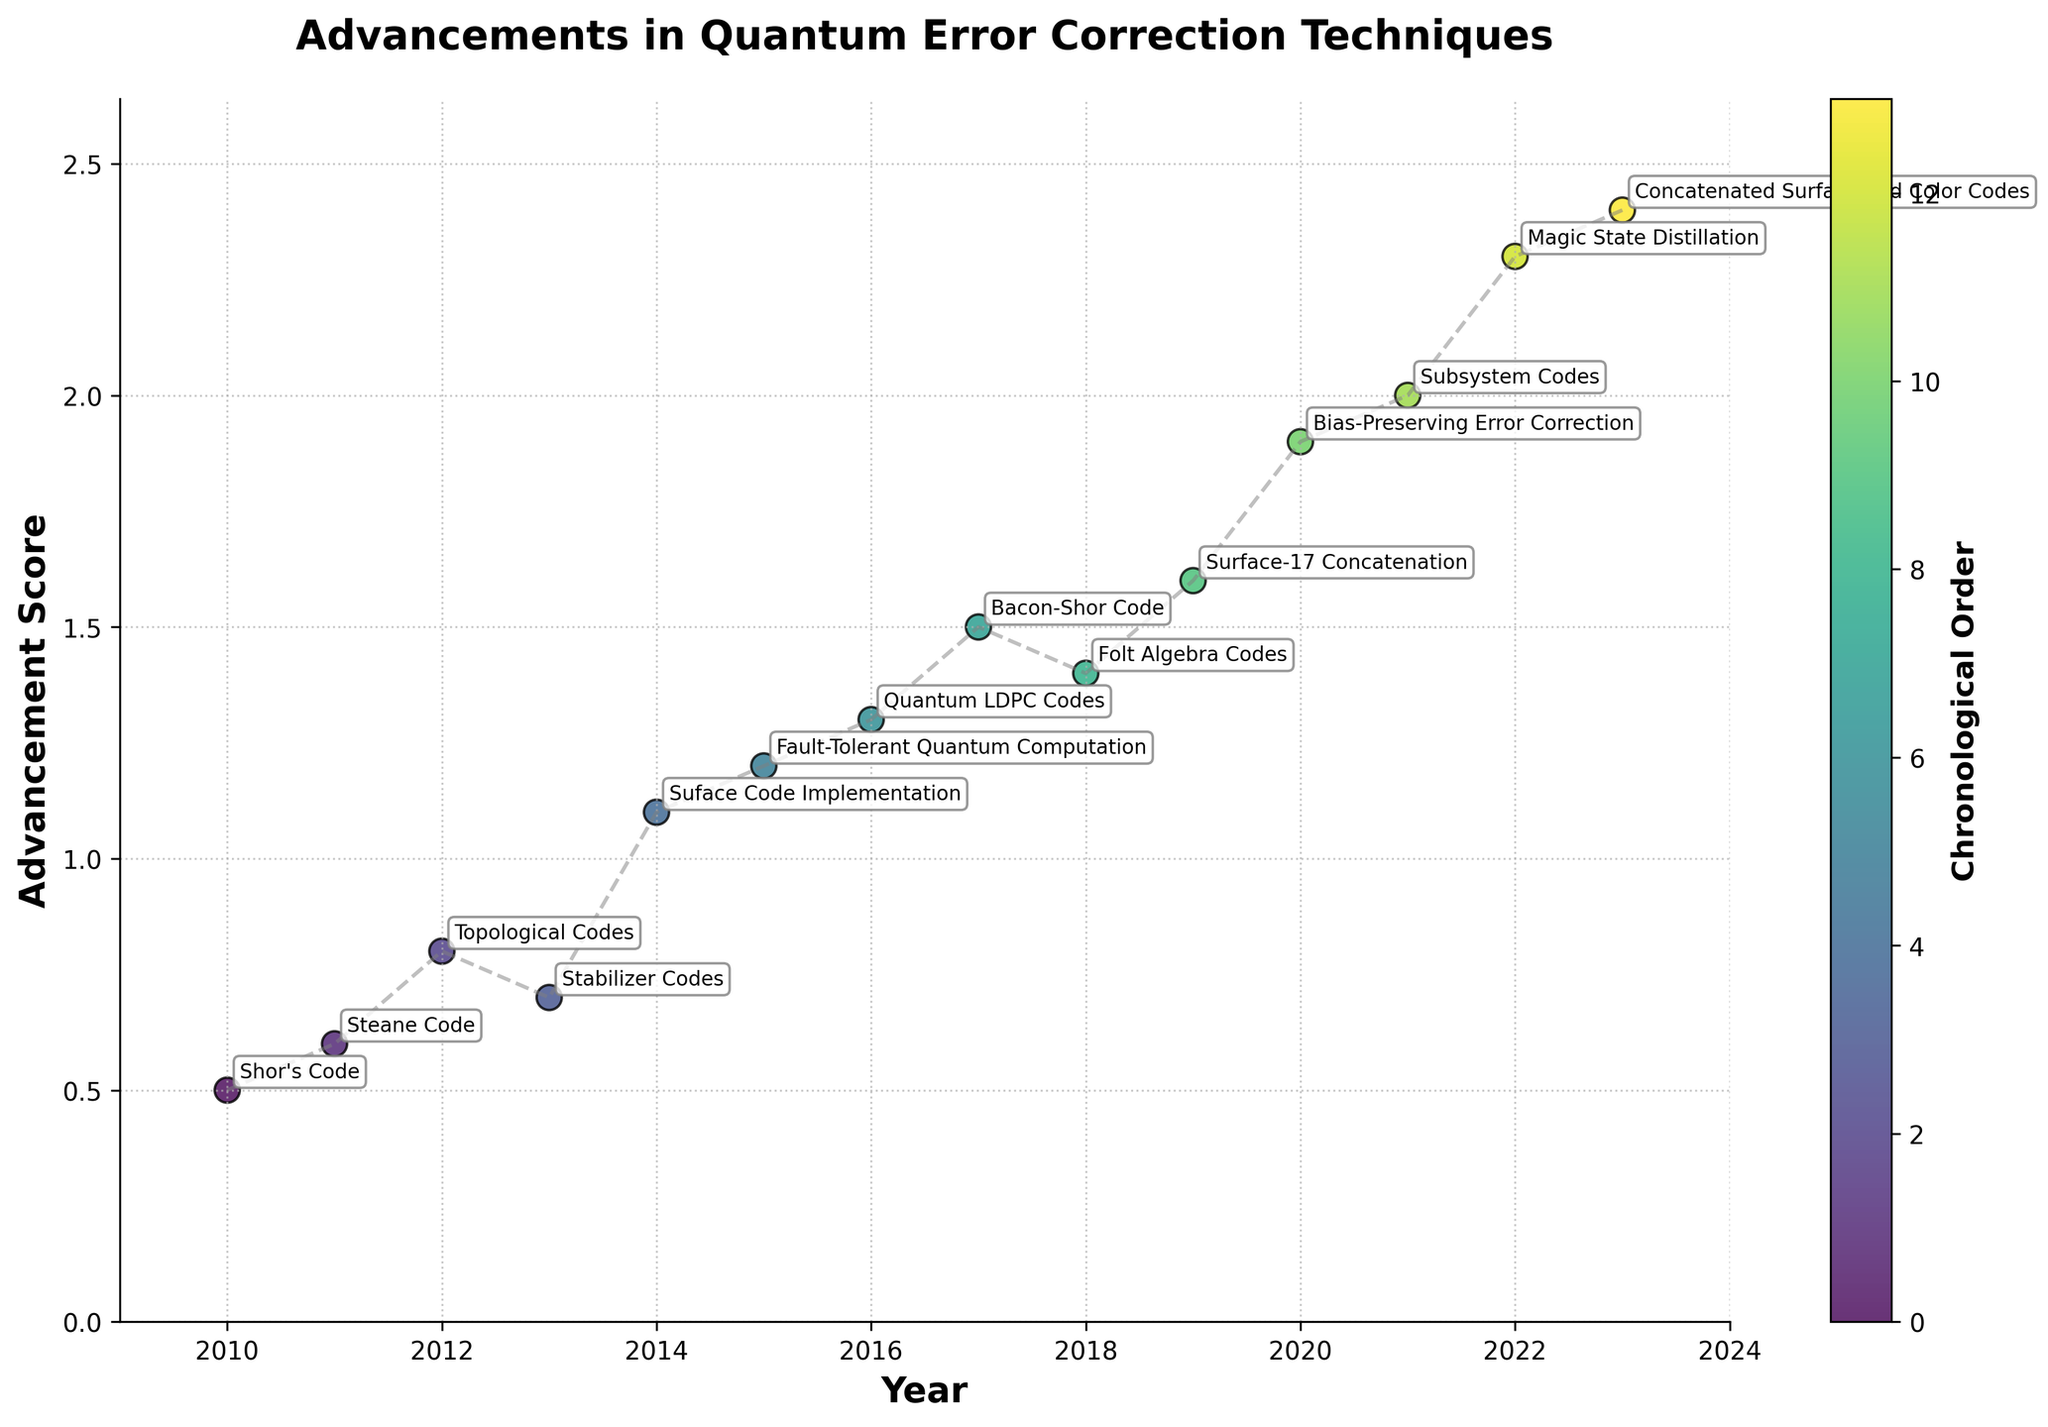What is the title of the figure? The title of the figure can be observed at the top of the plot. It describes the main subject of the visualization.
Answer: Advancements in Quantum Error Correction Techniques What is the range of years shown on the x-axis? The range of years on the x-axis can be determined by looking at the beginning and end of the axis labels, which span from the first to the last year included in the dataset.
Answer: 2010 to 2023 Which quantum error correction technique had the highest advancement score in the year 2022? By looking at the data points for the year 2022 and their labels, we can identify which technique corresponds to this year, and check its advancement score. The label "Magic State Distillation" is located at the highest position on the y-axis for 2022.
Answer: Magic State Distillation What is the mean advancement score from 2010 to 2023? To find the mean score, add all the advancement scores and divide by the number of years. The scores are: 0.5, 0.6, 0.8, 0.7, 1.1, 1.2, 1.3, 1.5, 1.4, 1.6, 1.9, 2.0, 2.3, 2.4. Sum is 19.3, and there are 14 years. Mean = 19.3 / 14.
Answer: 1.379 Which year saw the largest year-to-year increase in advancement score? To find the largest increase, calculate the difference in scores for each consecutive year and find the maximum. Between 2019 and 2020, the change is 1.9 - 1.6 = 0.3, which is the largest.
Answer: 2019 to 2020 How many quantum error correction techniques had an advancement score greater than 1.5? Count the data points that have advancement scores above 1.5. These are 2017 (Bacon-Shor Code), 2019 (Surface-17 Concatenation), 2020 (Bias-Preserving Error Correction), 2021 (Subsystem Codes), 2022 (Magic State Distillation), and 2023 (Concatenated Surface and Color Codes).
Answer: 6 Which technique was introduced in 2017, and what was its advancement score? Referencing the labeled data point for the year 2017, the technique is "Bacon-Shor Code" and its advancement score is located on the y-axis at that point.
Answer: Bacon-Shor Code, 1.5 What pattern can be observed in the advancement scores over the years? By observing the trend line connecting the points, it can be seen that the advancement scores generally increase over time with some fluctuations.
Answer: Increasing trend 